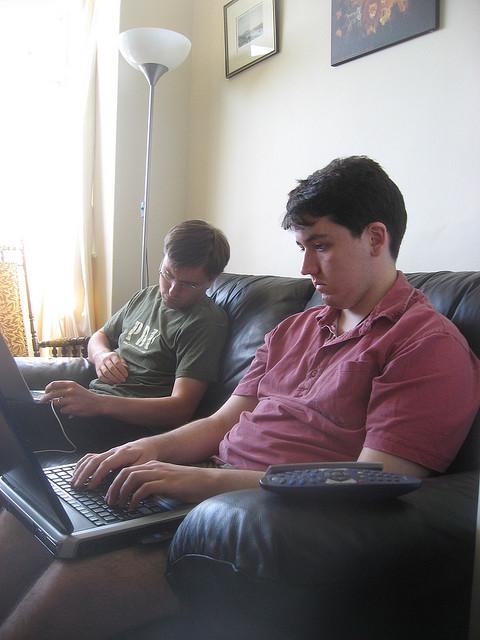What color is right man's shirt?
Concise answer only. Red. What is hanging in the background?
Concise answer only. Pictures. What is on the arm of the couch?
Give a very brief answer. Remote. What is outside the window?
Keep it brief. Sunlight. Why can't anyone see out the window?
Answer briefly. Curtain. Is the light on?
Give a very brief answer. No. What is this person's gender?
Give a very brief answer. Male. What emotion does this person have?
Be succinct. Bored. Does someone seem jubilant over something they know about?
Write a very short answer. No. 